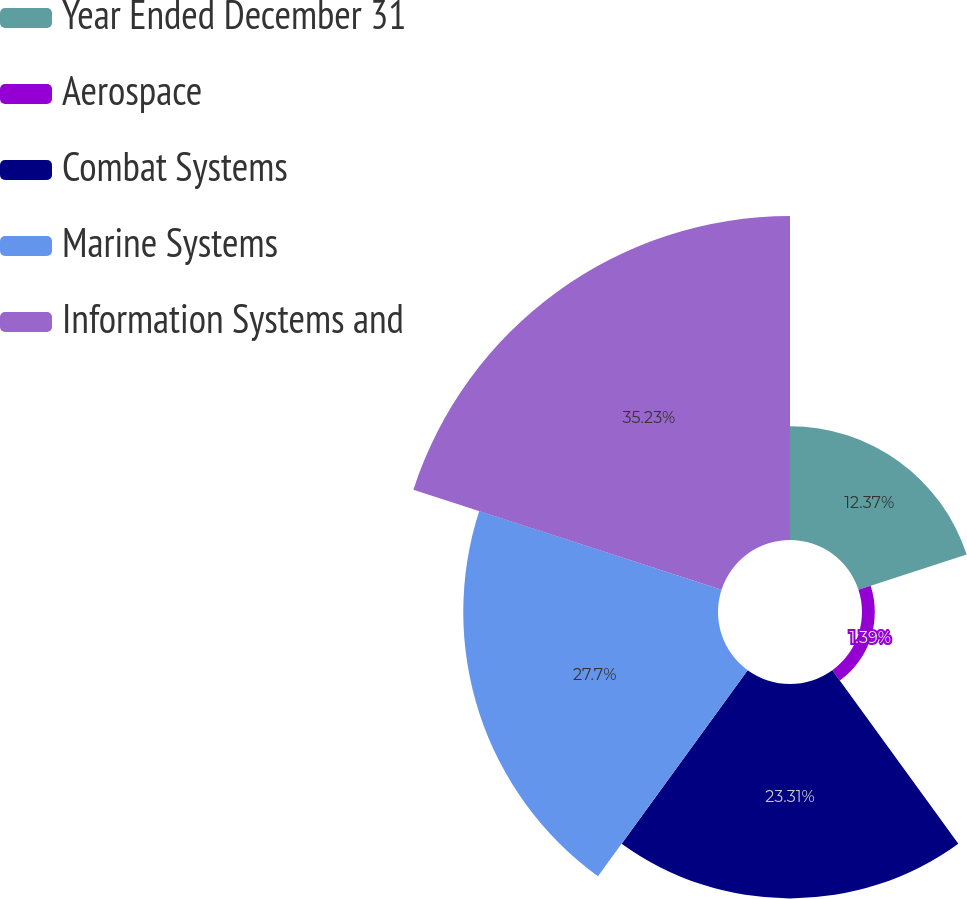Convert chart. <chart><loc_0><loc_0><loc_500><loc_500><pie_chart><fcel>Year Ended December 31<fcel>Aerospace<fcel>Combat Systems<fcel>Marine Systems<fcel>Information Systems and<nl><fcel>12.37%<fcel>1.39%<fcel>23.31%<fcel>27.7%<fcel>35.23%<nl></chart> 